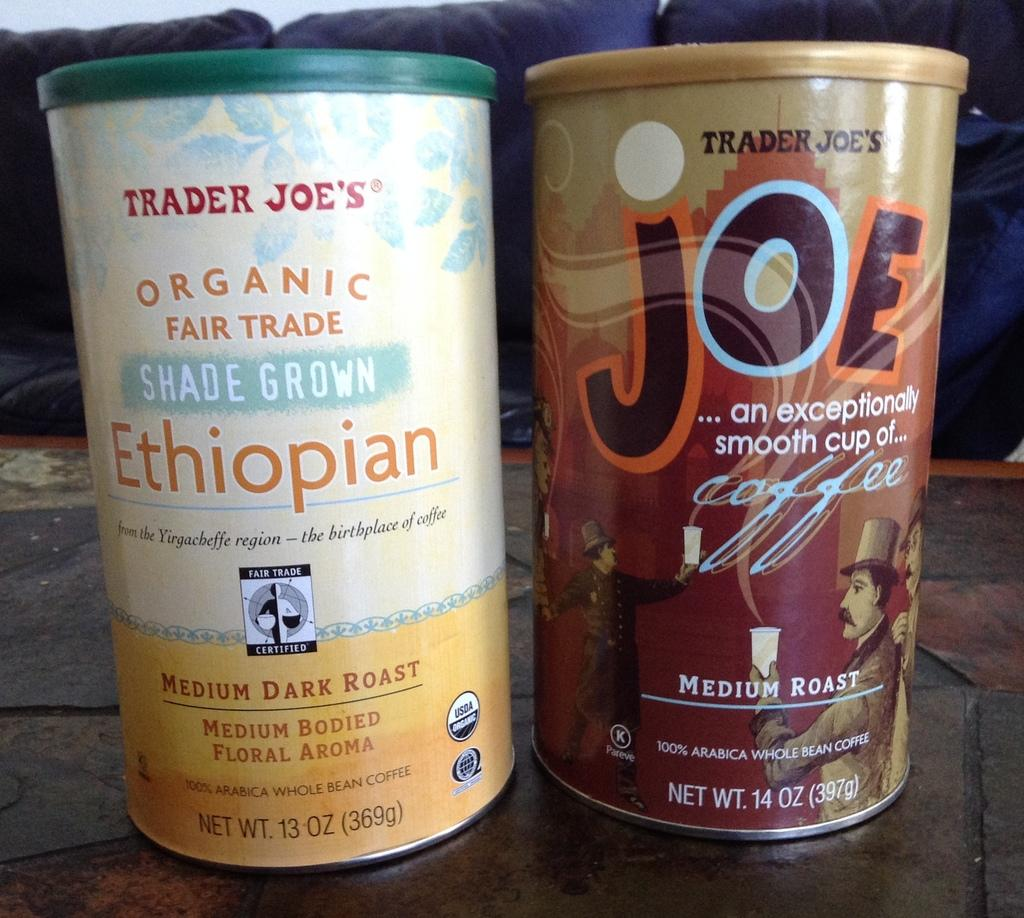<image>
Give a short and clear explanation of the subsequent image. an Ethiopian container next to one that says Joe 